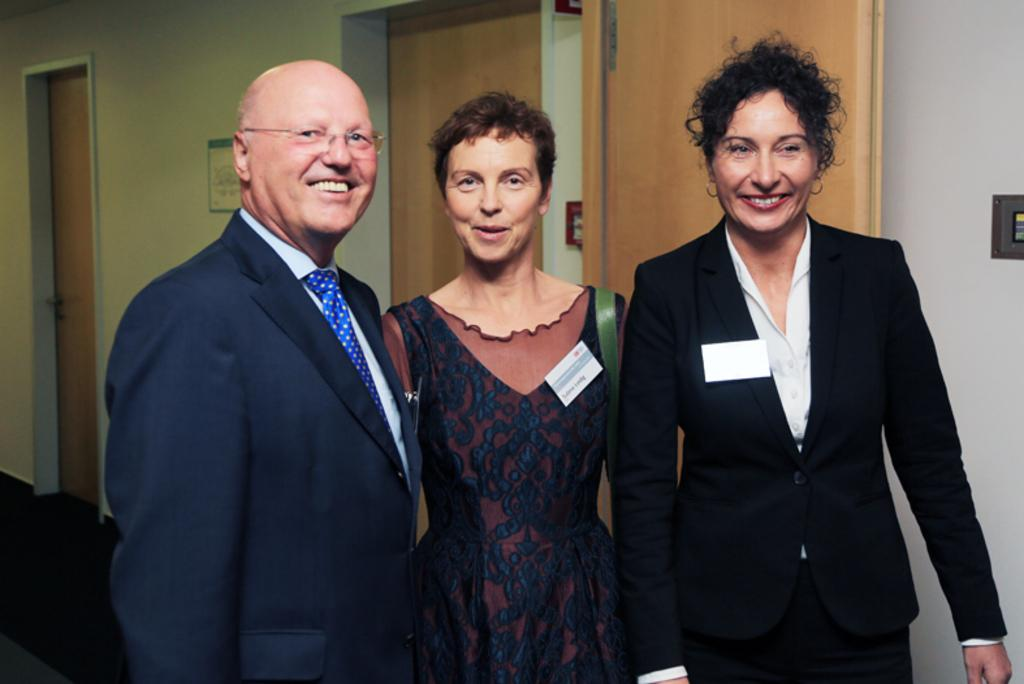What is happening in the center of the image? There are people standing in the center of the image. What can be seen in the background of the image? There are doors and a poster in the background of the image. What type of chalk is being used by the person in the image? There is no chalk present in the image. What is the person in the image doing with their neck? There is no person in the image using their neck for any specific action. 